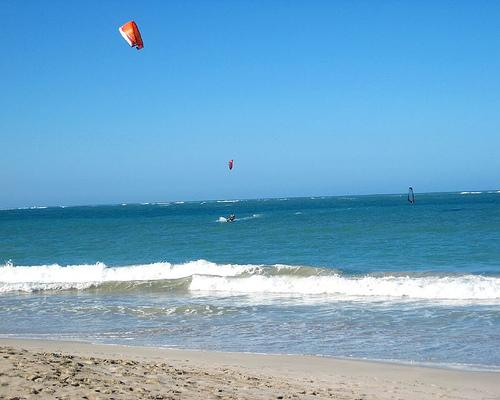To what is this sail attached? surfer 